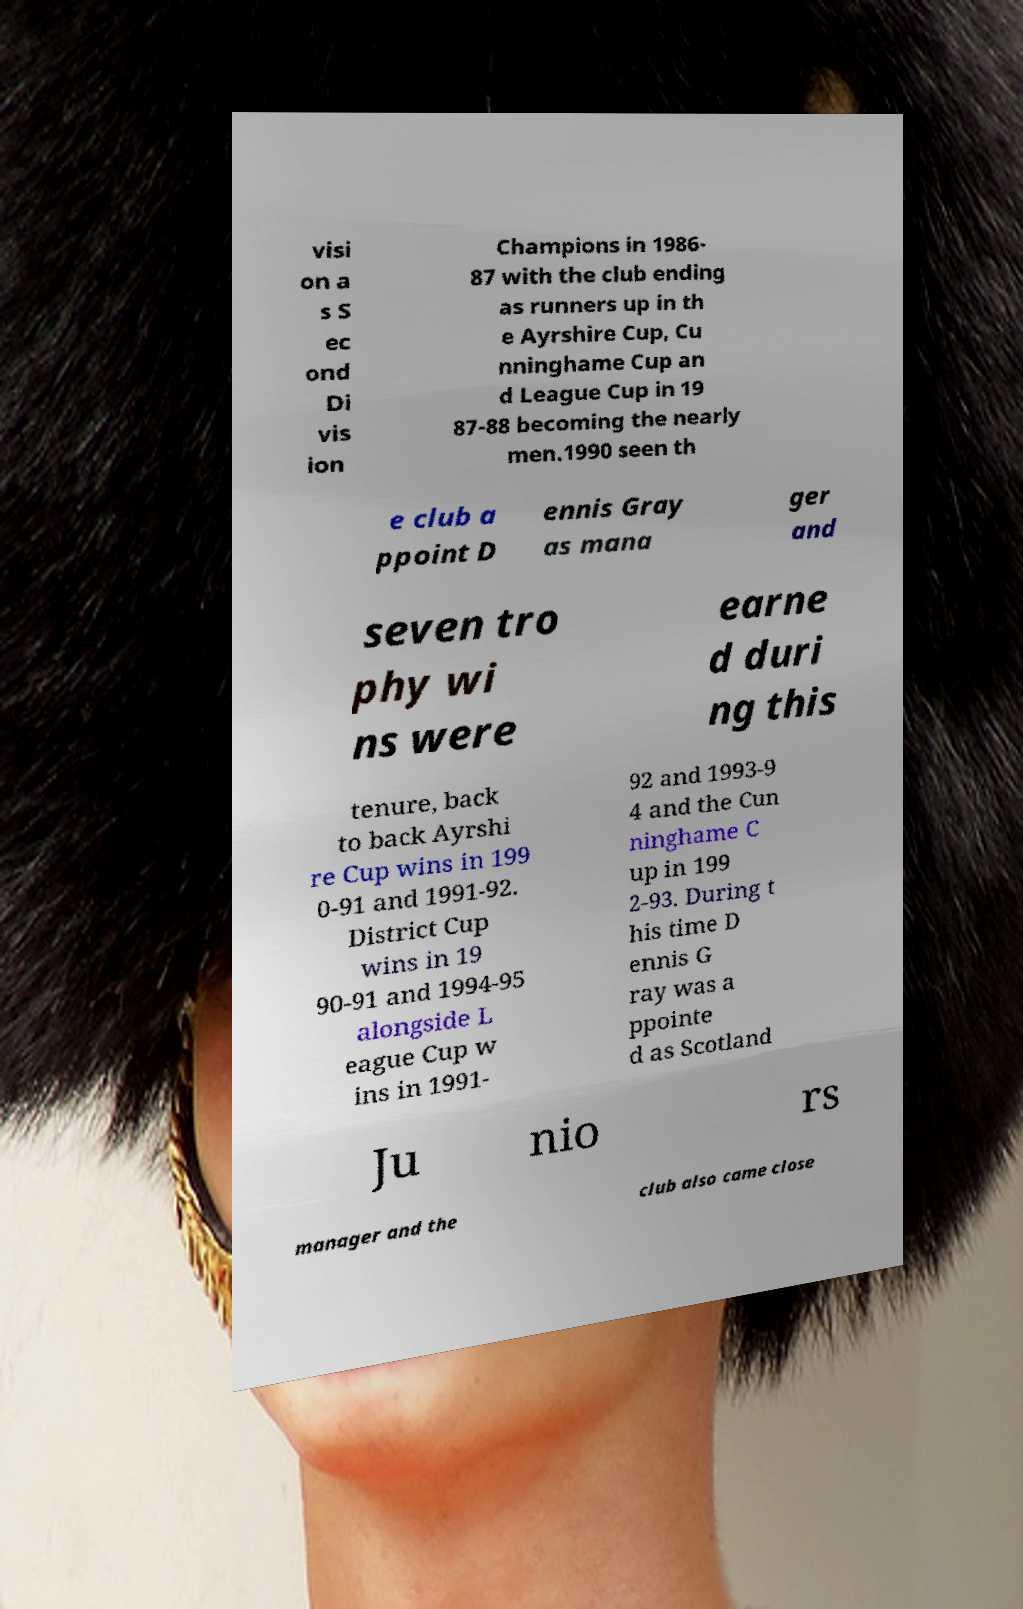There's text embedded in this image that I need extracted. Can you transcribe it verbatim? visi on a s S ec ond Di vis ion Champions in 1986- 87 with the club ending as runners up in th e Ayrshire Cup, Cu nninghame Cup an d League Cup in 19 87-88 becoming the nearly men.1990 seen th e club a ppoint D ennis Gray as mana ger and seven tro phy wi ns were earne d duri ng this tenure, back to back Ayrshi re Cup wins in 199 0-91 and 1991-92. District Cup wins in 19 90-91 and 1994-95 alongside L eague Cup w ins in 1991- 92 and 1993-9 4 and the Cun ninghame C up in 199 2-93. During t his time D ennis G ray was a ppointe d as Scotland Ju nio rs manager and the club also came close 